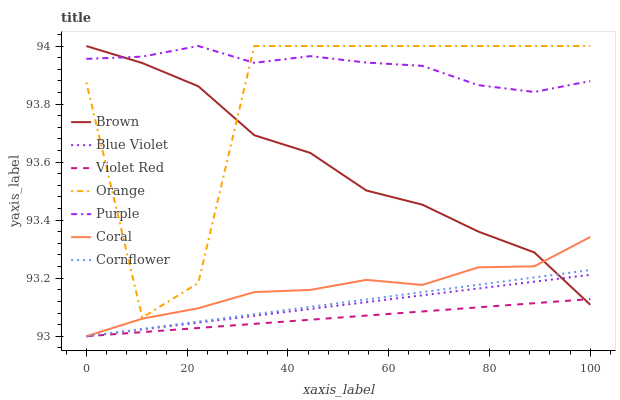Does Violet Red have the minimum area under the curve?
Answer yes or no. Yes. Does Purple have the maximum area under the curve?
Answer yes or no. Yes. Does Cornflower have the minimum area under the curve?
Answer yes or no. No. Does Cornflower have the maximum area under the curve?
Answer yes or no. No. Is Blue Violet the smoothest?
Answer yes or no. Yes. Is Orange the roughest?
Answer yes or no. Yes. Is Violet Red the smoothest?
Answer yes or no. No. Is Violet Red the roughest?
Answer yes or no. No. Does Violet Red have the lowest value?
Answer yes or no. Yes. Does Purple have the lowest value?
Answer yes or no. No. Does Orange have the highest value?
Answer yes or no. Yes. Does Cornflower have the highest value?
Answer yes or no. No. Is Violet Red less than Orange?
Answer yes or no. Yes. Is Purple greater than Coral?
Answer yes or no. Yes. Does Brown intersect Orange?
Answer yes or no. Yes. Is Brown less than Orange?
Answer yes or no. No. Is Brown greater than Orange?
Answer yes or no. No. Does Violet Red intersect Orange?
Answer yes or no. No. 